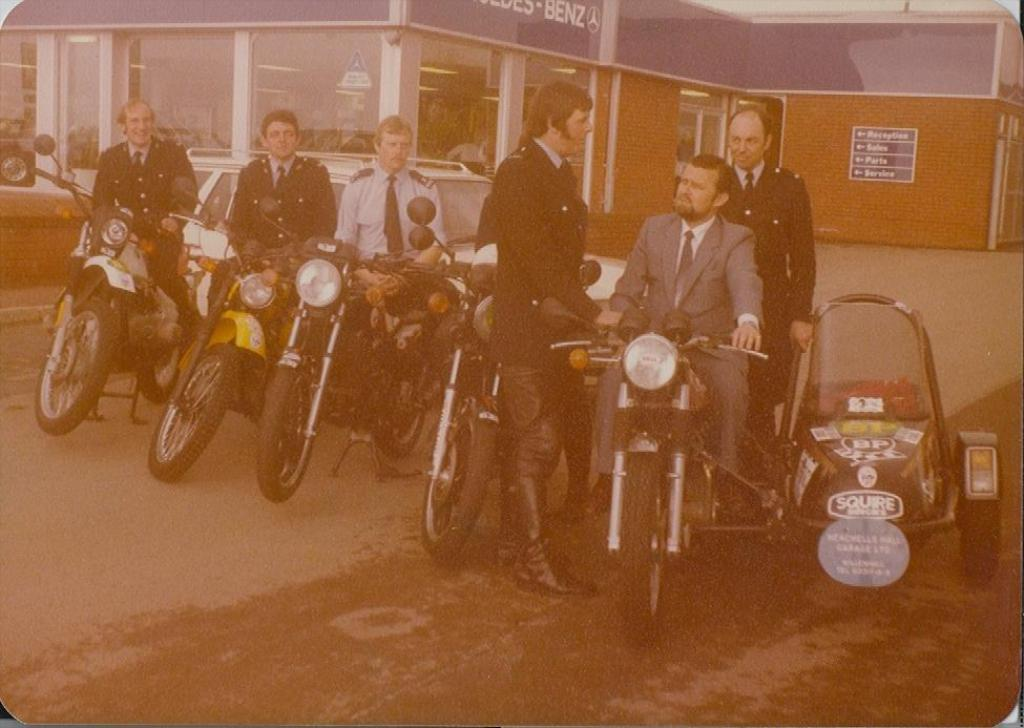What are the persons in the image doing? The persons in the image are sitting on a motorcycle. What else can be seen on the ground in the image? There is a car on the ground. What is visible in the background of the image? There is a building in the background. How many ladybugs can be seen on the motorcycle in the image? There are no ladybugs present in the image. What type of soup is being served in the car in the image? There is no soup or car serving soup in the image. 